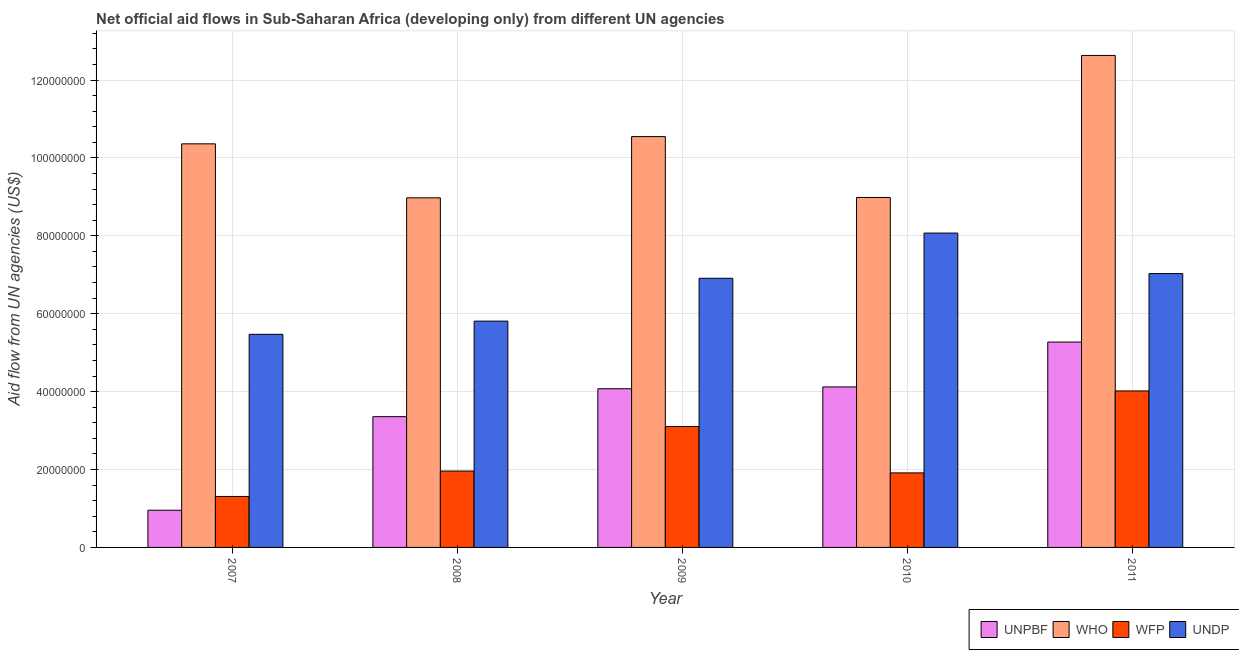Are the number of bars per tick equal to the number of legend labels?
Provide a succinct answer. Yes. How many bars are there on the 2nd tick from the right?
Give a very brief answer. 4. What is the label of the 1st group of bars from the left?
Ensure brevity in your answer.  2007. What is the amount of aid given by unpbf in 2007?
Ensure brevity in your answer.  9.55e+06. Across all years, what is the maximum amount of aid given by undp?
Give a very brief answer. 8.07e+07. Across all years, what is the minimum amount of aid given by unpbf?
Make the answer very short. 9.55e+06. In which year was the amount of aid given by unpbf minimum?
Give a very brief answer. 2007. What is the total amount of aid given by unpbf in the graph?
Offer a terse response. 1.78e+08. What is the difference between the amount of aid given by wfp in 2007 and that in 2009?
Provide a short and direct response. -1.80e+07. What is the difference between the amount of aid given by unpbf in 2008 and the amount of aid given by undp in 2007?
Offer a terse response. 2.40e+07. What is the average amount of aid given by who per year?
Your response must be concise. 1.03e+08. In the year 2010, what is the difference between the amount of aid given by unpbf and amount of aid given by undp?
Give a very brief answer. 0. What is the ratio of the amount of aid given by wfp in 2009 to that in 2010?
Offer a terse response. 1.62. Is the amount of aid given by who in 2008 less than that in 2009?
Offer a terse response. Yes. What is the difference between the highest and the second highest amount of aid given by unpbf?
Offer a terse response. 1.15e+07. What is the difference between the highest and the lowest amount of aid given by who?
Provide a short and direct response. 3.66e+07. Is it the case that in every year, the sum of the amount of aid given by who and amount of aid given by wfp is greater than the sum of amount of aid given by undp and amount of aid given by unpbf?
Keep it short and to the point. No. What does the 2nd bar from the left in 2010 represents?
Your response must be concise. WHO. What does the 2nd bar from the right in 2009 represents?
Ensure brevity in your answer.  WFP. Is it the case that in every year, the sum of the amount of aid given by unpbf and amount of aid given by who is greater than the amount of aid given by wfp?
Your response must be concise. Yes. How many bars are there?
Offer a terse response. 20. How many years are there in the graph?
Provide a short and direct response. 5. What is the difference between two consecutive major ticks on the Y-axis?
Keep it short and to the point. 2.00e+07. Are the values on the major ticks of Y-axis written in scientific E-notation?
Keep it short and to the point. No. Does the graph contain any zero values?
Offer a terse response. No. Where does the legend appear in the graph?
Your answer should be very brief. Bottom right. How are the legend labels stacked?
Offer a very short reply. Horizontal. What is the title of the graph?
Provide a short and direct response. Net official aid flows in Sub-Saharan Africa (developing only) from different UN agencies. What is the label or title of the X-axis?
Ensure brevity in your answer.  Year. What is the label or title of the Y-axis?
Give a very brief answer. Aid flow from UN agencies (US$). What is the Aid flow from UN agencies (US$) in UNPBF in 2007?
Ensure brevity in your answer.  9.55e+06. What is the Aid flow from UN agencies (US$) of WHO in 2007?
Give a very brief answer. 1.04e+08. What is the Aid flow from UN agencies (US$) of WFP in 2007?
Provide a succinct answer. 1.31e+07. What is the Aid flow from UN agencies (US$) of UNDP in 2007?
Provide a succinct answer. 5.47e+07. What is the Aid flow from UN agencies (US$) in UNPBF in 2008?
Provide a short and direct response. 3.36e+07. What is the Aid flow from UN agencies (US$) of WHO in 2008?
Provide a short and direct response. 8.98e+07. What is the Aid flow from UN agencies (US$) of WFP in 2008?
Offer a terse response. 1.96e+07. What is the Aid flow from UN agencies (US$) of UNDP in 2008?
Provide a short and direct response. 5.81e+07. What is the Aid flow from UN agencies (US$) of UNPBF in 2009?
Keep it short and to the point. 4.07e+07. What is the Aid flow from UN agencies (US$) in WHO in 2009?
Keep it short and to the point. 1.05e+08. What is the Aid flow from UN agencies (US$) of WFP in 2009?
Ensure brevity in your answer.  3.10e+07. What is the Aid flow from UN agencies (US$) in UNDP in 2009?
Provide a short and direct response. 6.91e+07. What is the Aid flow from UN agencies (US$) in UNPBF in 2010?
Keep it short and to the point. 4.12e+07. What is the Aid flow from UN agencies (US$) of WHO in 2010?
Keep it short and to the point. 8.98e+07. What is the Aid flow from UN agencies (US$) in WFP in 2010?
Your answer should be compact. 1.91e+07. What is the Aid flow from UN agencies (US$) of UNDP in 2010?
Your response must be concise. 8.07e+07. What is the Aid flow from UN agencies (US$) of UNPBF in 2011?
Your answer should be very brief. 5.27e+07. What is the Aid flow from UN agencies (US$) in WHO in 2011?
Your answer should be very brief. 1.26e+08. What is the Aid flow from UN agencies (US$) in WFP in 2011?
Your answer should be compact. 4.02e+07. What is the Aid flow from UN agencies (US$) in UNDP in 2011?
Your response must be concise. 7.03e+07. Across all years, what is the maximum Aid flow from UN agencies (US$) of UNPBF?
Your answer should be compact. 5.27e+07. Across all years, what is the maximum Aid flow from UN agencies (US$) of WHO?
Ensure brevity in your answer.  1.26e+08. Across all years, what is the maximum Aid flow from UN agencies (US$) in WFP?
Ensure brevity in your answer.  4.02e+07. Across all years, what is the maximum Aid flow from UN agencies (US$) in UNDP?
Give a very brief answer. 8.07e+07. Across all years, what is the minimum Aid flow from UN agencies (US$) in UNPBF?
Give a very brief answer. 9.55e+06. Across all years, what is the minimum Aid flow from UN agencies (US$) in WHO?
Make the answer very short. 8.98e+07. Across all years, what is the minimum Aid flow from UN agencies (US$) of WFP?
Your answer should be compact. 1.31e+07. Across all years, what is the minimum Aid flow from UN agencies (US$) of UNDP?
Keep it short and to the point. 5.47e+07. What is the total Aid flow from UN agencies (US$) in UNPBF in the graph?
Your answer should be compact. 1.78e+08. What is the total Aid flow from UN agencies (US$) of WHO in the graph?
Your response must be concise. 5.15e+08. What is the total Aid flow from UN agencies (US$) in WFP in the graph?
Offer a terse response. 1.23e+08. What is the total Aid flow from UN agencies (US$) in UNDP in the graph?
Keep it short and to the point. 3.33e+08. What is the difference between the Aid flow from UN agencies (US$) of UNPBF in 2007 and that in 2008?
Your response must be concise. -2.40e+07. What is the difference between the Aid flow from UN agencies (US$) of WHO in 2007 and that in 2008?
Keep it short and to the point. 1.39e+07. What is the difference between the Aid flow from UN agencies (US$) of WFP in 2007 and that in 2008?
Provide a short and direct response. -6.53e+06. What is the difference between the Aid flow from UN agencies (US$) of UNDP in 2007 and that in 2008?
Your response must be concise. -3.39e+06. What is the difference between the Aid flow from UN agencies (US$) in UNPBF in 2007 and that in 2009?
Your answer should be compact. -3.12e+07. What is the difference between the Aid flow from UN agencies (US$) of WHO in 2007 and that in 2009?
Your answer should be compact. -1.86e+06. What is the difference between the Aid flow from UN agencies (US$) of WFP in 2007 and that in 2009?
Keep it short and to the point. -1.80e+07. What is the difference between the Aid flow from UN agencies (US$) in UNDP in 2007 and that in 2009?
Make the answer very short. -1.44e+07. What is the difference between the Aid flow from UN agencies (US$) of UNPBF in 2007 and that in 2010?
Make the answer very short. -3.17e+07. What is the difference between the Aid flow from UN agencies (US$) in WHO in 2007 and that in 2010?
Your answer should be very brief. 1.38e+07. What is the difference between the Aid flow from UN agencies (US$) in WFP in 2007 and that in 2010?
Offer a very short reply. -6.06e+06. What is the difference between the Aid flow from UN agencies (US$) in UNDP in 2007 and that in 2010?
Your answer should be compact. -2.60e+07. What is the difference between the Aid flow from UN agencies (US$) of UNPBF in 2007 and that in 2011?
Ensure brevity in your answer.  -4.32e+07. What is the difference between the Aid flow from UN agencies (US$) in WHO in 2007 and that in 2011?
Your answer should be compact. -2.27e+07. What is the difference between the Aid flow from UN agencies (US$) of WFP in 2007 and that in 2011?
Your response must be concise. -2.71e+07. What is the difference between the Aid flow from UN agencies (US$) in UNDP in 2007 and that in 2011?
Provide a succinct answer. -1.56e+07. What is the difference between the Aid flow from UN agencies (US$) of UNPBF in 2008 and that in 2009?
Your answer should be very brief. -7.17e+06. What is the difference between the Aid flow from UN agencies (US$) in WHO in 2008 and that in 2009?
Make the answer very short. -1.57e+07. What is the difference between the Aid flow from UN agencies (US$) in WFP in 2008 and that in 2009?
Offer a very short reply. -1.14e+07. What is the difference between the Aid flow from UN agencies (US$) of UNDP in 2008 and that in 2009?
Provide a succinct answer. -1.10e+07. What is the difference between the Aid flow from UN agencies (US$) in UNPBF in 2008 and that in 2010?
Your response must be concise. -7.64e+06. What is the difference between the Aid flow from UN agencies (US$) in WFP in 2008 and that in 2010?
Make the answer very short. 4.70e+05. What is the difference between the Aid flow from UN agencies (US$) of UNDP in 2008 and that in 2010?
Your answer should be very brief. -2.26e+07. What is the difference between the Aid flow from UN agencies (US$) of UNPBF in 2008 and that in 2011?
Ensure brevity in your answer.  -1.92e+07. What is the difference between the Aid flow from UN agencies (US$) in WHO in 2008 and that in 2011?
Your response must be concise. -3.66e+07. What is the difference between the Aid flow from UN agencies (US$) of WFP in 2008 and that in 2011?
Give a very brief answer. -2.06e+07. What is the difference between the Aid flow from UN agencies (US$) in UNDP in 2008 and that in 2011?
Offer a terse response. -1.22e+07. What is the difference between the Aid flow from UN agencies (US$) of UNPBF in 2009 and that in 2010?
Your answer should be compact. -4.70e+05. What is the difference between the Aid flow from UN agencies (US$) of WHO in 2009 and that in 2010?
Provide a succinct answer. 1.56e+07. What is the difference between the Aid flow from UN agencies (US$) of WFP in 2009 and that in 2010?
Your answer should be very brief. 1.19e+07. What is the difference between the Aid flow from UN agencies (US$) of UNDP in 2009 and that in 2010?
Offer a terse response. -1.16e+07. What is the difference between the Aid flow from UN agencies (US$) in UNPBF in 2009 and that in 2011?
Ensure brevity in your answer.  -1.20e+07. What is the difference between the Aid flow from UN agencies (US$) in WHO in 2009 and that in 2011?
Your answer should be compact. -2.08e+07. What is the difference between the Aid flow from UN agencies (US$) in WFP in 2009 and that in 2011?
Your answer should be very brief. -9.14e+06. What is the difference between the Aid flow from UN agencies (US$) of UNDP in 2009 and that in 2011?
Ensure brevity in your answer.  -1.20e+06. What is the difference between the Aid flow from UN agencies (US$) in UNPBF in 2010 and that in 2011?
Provide a succinct answer. -1.15e+07. What is the difference between the Aid flow from UN agencies (US$) in WHO in 2010 and that in 2011?
Offer a very short reply. -3.65e+07. What is the difference between the Aid flow from UN agencies (US$) in WFP in 2010 and that in 2011?
Your answer should be very brief. -2.10e+07. What is the difference between the Aid flow from UN agencies (US$) of UNDP in 2010 and that in 2011?
Offer a very short reply. 1.04e+07. What is the difference between the Aid flow from UN agencies (US$) in UNPBF in 2007 and the Aid flow from UN agencies (US$) in WHO in 2008?
Your response must be concise. -8.02e+07. What is the difference between the Aid flow from UN agencies (US$) of UNPBF in 2007 and the Aid flow from UN agencies (US$) of WFP in 2008?
Your response must be concise. -1.01e+07. What is the difference between the Aid flow from UN agencies (US$) of UNPBF in 2007 and the Aid flow from UN agencies (US$) of UNDP in 2008?
Ensure brevity in your answer.  -4.86e+07. What is the difference between the Aid flow from UN agencies (US$) in WHO in 2007 and the Aid flow from UN agencies (US$) in WFP in 2008?
Keep it short and to the point. 8.40e+07. What is the difference between the Aid flow from UN agencies (US$) of WHO in 2007 and the Aid flow from UN agencies (US$) of UNDP in 2008?
Provide a short and direct response. 4.55e+07. What is the difference between the Aid flow from UN agencies (US$) in WFP in 2007 and the Aid flow from UN agencies (US$) in UNDP in 2008?
Your answer should be compact. -4.50e+07. What is the difference between the Aid flow from UN agencies (US$) in UNPBF in 2007 and the Aid flow from UN agencies (US$) in WHO in 2009?
Keep it short and to the point. -9.59e+07. What is the difference between the Aid flow from UN agencies (US$) of UNPBF in 2007 and the Aid flow from UN agencies (US$) of WFP in 2009?
Provide a short and direct response. -2.15e+07. What is the difference between the Aid flow from UN agencies (US$) of UNPBF in 2007 and the Aid flow from UN agencies (US$) of UNDP in 2009?
Provide a succinct answer. -5.96e+07. What is the difference between the Aid flow from UN agencies (US$) in WHO in 2007 and the Aid flow from UN agencies (US$) in WFP in 2009?
Your response must be concise. 7.26e+07. What is the difference between the Aid flow from UN agencies (US$) of WHO in 2007 and the Aid flow from UN agencies (US$) of UNDP in 2009?
Provide a succinct answer. 3.45e+07. What is the difference between the Aid flow from UN agencies (US$) in WFP in 2007 and the Aid flow from UN agencies (US$) in UNDP in 2009?
Provide a short and direct response. -5.60e+07. What is the difference between the Aid flow from UN agencies (US$) in UNPBF in 2007 and the Aid flow from UN agencies (US$) in WHO in 2010?
Your response must be concise. -8.03e+07. What is the difference between the Aid flow from UN agencies (US$) in UNPBF in 2007 and the Aid flow from UN agencies (US$) in WFP in 2010?
Offer a terse response. -9.59e+06. What is the difference between the Aid flow from UN agencies (US$) in UNPBF in 2007 and the Aid flow from UN agencies (US$) in UNDP in 2010?
Make the answer very short. -7.12e+07. What is the difference between the Aid flow from UN agencies (US$) of WHO in 2007 and the Aid flow from UN agencies (US$) of WFP in 2010?
Keep it short and to the point. 8.45e+07. What is the difference between the Aid flow from UN agencies (US$) in WHO in 2007 and the Aid flow from UN agencies (US$) in UNDP in 2010?
Offer a very short reply. 2.29e+07. What is the difference between the Aid flow from UN agencies (US$) of WFP in 2007 and the Aid flow from UN agencies (US$) of UNDP in 2010?
Ensure brevity in your answer.  -6.76e+07. What is the difference between the Aid flow from UN agencies (US$) of UNPBF in 2007 and the Aid flow from UN agencies (US$) of WHO in 2011?
Your answer should be very brief. -1.17e+08. What is the difference between the Aid flow from UN agencies (US$) of UNPBF in 2007 and the Aid flow from UN agencies (US$) of WFP in 2011?
Your response must be concise. -3.06e+07. What is the difference between the Aid flow from UN agencies (US$) in UNPBF in 2007 and the Aid flow from UN agencies (US$) in UNDP in 2011?
Your answer should be compact. -6.08e+07. What is the difference between the Aid flow from UN agencies (US$) in WHO in 2007 and the Aid flow from UN agencies (US$) in WFP in 2011?
Provide a succinct answer. 6.34e+07. What is the difference between the Aid flow from UN agencies (US$) in WHO in 2007 and the Aid flow from UN agencies (US$) in UNDP in 2011?
Give a very brief answer. 3.33e+07. What is the difference between the Aid flow from UN agencies (US$) in WFP in 2007 and the Aid flow from UN agencies (US$) in UNDP in 2011?
Provide a short and direct response. -5.72e+07. What is the difference between the Aid flow from UN agencies (US$) in UNPBF in 2008 and the Aid flow from UN agencies (US$) in WHO in 2009?
Provide a short and direct response. -7.19e+07. What is the difference between the Aid flow from UN agencies (US$) of UNPBF in 2008 and the Aid flow from UN agencies (US$) of WFP in 2009?
Keep it short and to the point. 2.53e+06. What is the difference between the Aid flow from UN agencies (US$) of UNPBF in 2008 and the Aid flow from UN agencies (US$) of UNDP in 2009?
Ensure brevity in your answer.  -3.55e+07. What is the difference between the Aid flow from UN agencies (US$) in WHO in 2008 and the Aid flow from UN agencies (US$) in WFP in 2009?
Offer a very short reply. 5.87e+07. What is the difference between the Aid flow from UN agencies (US$) in WHO in 2008 and the Aid flow from UN agencies (US$) in UNDP in 2009?
Your response must be concise. 2.06e+07. What is the difference between the Aid flow from UN agencies (US$) in WFP in 2008 and the Aid flow from UN agencies (US$) in UNDP in 2009?
Your response must be concise. -4.95e+07. What is the difference between the Aid flow from UN agencies (US$) in UNPBF in 2008 and the Aid flow from UN agencies (US$) in WHO in 2010?
Ensure brevity in your answer.  -5.63e+07. What is the difference between the Aid flow from UN agencies (US$) in UNPBF in 2008 and the Aid flow from UN agencies (US$) in WFP in 2010?
Keep it short and to the point. 1.44e+07. What is the difference between the Aid flow from UN agencies (US$) in UNPBF in 2008 and the Aid flow from UN agencies (US$) in UNDP in 2010?
Keep it short and to the point. -4.71e+07. What is the difference between the Aid flow from UN agencies (US$) in WHO in 2008 and the Aid flow from UN agencies (US$) in WFP in 2010?
Offer a very short reply. 7.06e+07. What is the difference between the Aid flow from UN agencies (US$) of WHO in 2008 and the Aid flow from UN agencies (US$) of UNDP in 2010?
Your answer should be very brief. 9.05e+06. What is the difference between the Aid flow from UN agencies (US$) in WFP in 2008 and the Aid flow from UN agencies (US$) in UNDP in 2010?
Ensure brevity in your answer.  -6.11e+07. What is the difference between the Aid flow from UN agencies (US$) of UNPBF in 2008 and the Aid flow from UN agencies (US$) of WHO in 2011?
Offer a very short reply. -9.28e+07. What is the difference between the Aid flow from UN agencies (US$) of UNPBF in 2008 and the Aid flow from UN agencies (US$) of WFP in 2011?
Give a very brief answer. -6.61e+06. What is the difference between the Aid flow from UN agencies (US$) in UNPBF in 2008 and the Aid flow from UN agencies (US$) in UNDP in 2011?
Your response must be concise. -3.67e+07. What is the difference between the Aid flow from UN agencies (US$) in WHO in 2008 and the Aid flow from UN agencies (US$) in WFP in 2011?
Offer a very short reply. 4.96e+07. What is the difference between the Aid flow from UN agencies (US$) of WHO in 2008 and the Aid flow from UN agencies (US$) of UNDP in 2011?
Provide a short and direct response. 1.94e+07. What is the difference between the Aid flow from UN agencies (US$) in WFP in 2008 and the Aid flow from UN agencies (US$) in UNDP in 2011?
Give a very brief answer. -5.07e+07. What is the difference between the Aid flow from UN agencies (US$) of UNPBF in 2009 and the Aid flow from UN agencies (US$) of WHO in 2010?
Provide a short and direct response. -4.91e+07. What is the difference between the Aid flow from UN agencies (US$) of UNPBF in 2009 and the Aid flow from UN agencies (US$) of WFP in 2010?
Your response must be concise. 2.16e+07. What is the difference between the Aid flow from UN agencies (US$) of UNPBF in 2009 and the Aid flow from UN agencies (US$) of UNDP in 2010?
Ensure brevity in your answer.  -4.00e+07. What is the difference between the Aid flow from UN agencies (US$) of WHO in 2009 and the Aid flow from UN agencies (US$) of WFP in 2010?
Offer a terse response. 8.63e+07. What is the difference between the Aid flow from UN agencies (US$) in WHO in 2009 and the Aid flow from UN agencies (US$) in UNDP in 2010?
Your answer should be compact. 2.48e+07. What is the difference between the Aid flow from UN agencies (US$) of WFP in 2009 and the Aid flow from UN agencies (US$) of UNDP in 2010?
Your answer should be very brief. -4.97e+07. What is the difference between the Aid flow from UN agencies (US$) of UNPBF in 2009 and the Aid flow from UN agencies (US$) of WHO in 2011?
Your answer should be very brief. -8.56e+07. What is the difference between the Aid flow from UN agencies (US$) in UNPBF in 2009 and the Aid flow from UN agencies (US$) in WFP in 2011?
Give a very brief answer. 5.60e+05. What is the difference between the Aid flow from UN agencies (US$) in UNPBF in 2009 and the Aid flow from UN agencies (US$) in UNDP in 2011?
Offer a very short reply. -2.96e+07. What is the difference between the Aid flow from UN agencies (US$) of WHO in 2009 and the Aid flow from UN agencies (US$) of WFP in 2011?
Keep it short and to the point. 6.53e+07. What is the difference between the Aid flow from UN agencies (US$) in WHO in 2009 and the Aid flow from UN agencies (US$) in UNDP in 2011?
Your answer should be compact. 3.52e+07. What is the difference between the Aid flow from UN agencies (US$) of WFP in 2009 and the Aid flow from UN agencies (US$) of UNDP in 2011?
Your answer should be compact. -3.93e+07. What is the difference between the Aid flow from UN agencies (US$) in UNPBF in 2010 and the Aid flow from UN agencies (US$) in WHO in 2011?
Your answer should be very brief. -8.51e+07. What is the difference between the Aid flow from UN agencies (US$) of UNPBF in 2010 and the Aid flow from UN agencies (US$) of WFP in 2011?
Your response must be concise. 1.03e+06. What is the difference between the Aid flow from UN agencies (US$) in UNPBF in 2010 and the Aid flow from UN agencies (US$) in UNDP in 2011?
Provide a short and direct response. -2.91e+07. What is the difference between the Aid flow from UN agencies (US$) in WHO in 2010 and the Aid flow from UN agencies (US$) in WFP in 2011?
Give a very brief answer. 4.97e+07. What is the difference between the Aid flow from UN agencies (US$) in WHO in 2010 and the Aid flow from UN agencies (US$) in UNDP in 2011?
Ensure brevity in your answer.  1.95e+07. What is the difference between the Aid flow from UN agencies (US$) in WFP in 2010 and the Aid flow from UN agencies (US$) in UNDP in 2011?
Your answer should be very brief. -5.12e+07. What is the average Aid flow from UN agencies (US$) in UNPBF per year?
Provide a short and direct response. 3.56e+07. What is the average Aid flow from UN agencies (US$) of WHO per year?
Ensure brevity in your answer.  1.03e+08. What is the average Aid flow from UN agencies (US$) in WFP per year?
Provide a succinct answer. 2.46e+07. What is the average Aid flow from UN agencies (US$) of UNDP per year?
Your answer should be very brief. 6.66e+07. In the year 2007, what is the difference between the Aid flow from UN agencies (US$) in UNPBF and Aid flow from UN agencies (US$) in WHO?
Your response must be concise. -9.41e+07. In the year 2007, what is the difference between the Aid flow from UN agencies (US$) of UNPBF and Aid flow from UN agencies (US$) of WFP?
Your answer should be very brief. -3.53e+06. In the year 2007, what is the difference between the Aid flow from UN agencies (US$) in UNPBF and Aid flow from UN agencies (US$) in UNDP?
Keep it short and to the point. -4.52e+07. In the year 2007, what is the difference between the Aid flow from UN agencies (US$) in WHO and Aid flow from UN agencies (US$) in WFP?
Your answer should be very brief. 9.05e+07. In the year 2007, what is the difference between the Aid flow from UN agencies (US$) in WHO and Aid flow from UN agencies (US$) in UNDP?
Offer a very short reply. 4.89e+07. In the year 2007, what is the difference between the Aid flow from UN agencies (US$) in WFP and Aid flow from UN agencies (US$) in UNDP?
Your answer should be compact. -4.16e+07. In the year 2008, what is the difference between the Aid flow from UN agencies (US$) of UNPBF and Aid flow from UN agencies (US$) of WHO?
Offer a very short reply. -5.62e+07. In the year 2008, what is the difference between the Aid flow from UN agencies (US$) of UNPBF and Aid flow from UN agencies (US$) of WFP?
Give a very brief answer. 1.40e+07. In the year 2008, what is the difference between the Aid flow from UN agencies (US$) of UNPBF and Aid flow from UN agencies (US$) of UNDP?
Give a very brief answer. -2.45e+07. In the year 2008, what is the difference between the Aid flow from UN agencies (US$) of WHO and Aid flow from UN agencies (US$) of WFP?
Provide a short and direct response. 7.02e+07. In the year 2008, what is the difference between the Aid flow from UN agencies (US$) of WHO and Aid flow from UN agencies (US$) of UNDP?
Offer a very short reply. 3.17e+07. In the year 2008, what is the difference between the Aid flow from UN agencies (US$) of WFP and Aid flow from UN agencies (US$) of UNDP?
Offer a terse response. -3.85e+07. In the year 2009, what is the difference between the Aid flow from UN agencies (US$) of UNPBF and Aid flow from UN agencies (US$) of WHO?
Your response must be concise. -6.47e+07. In the year 2009, what is the difference between the Aid flow from UN agencies (US$) of UNPBF and Aid flow from UN agencies (US$) of WFP?
Your response must be concise. 9.70e+06. In the year 2009, what is the difference between the Aid flow from UN agencies (US$) in UNPBF and Aid flow from UN agencies (US$) in UNDP?
Give a very brief answer. -2.84e+07. In the year 2009, what is the difference between the Aid flow from UN agencies (US$) of WHO and Aid flow from UN agencies (US$) of WFP?
Offer a terse response. 7.44e+07. In the year 2009, what is the difference between the Aid flow from UN agencies (US$) of WHO and Aid flow from UN agencies (US$) of UNDP?
Offer a terse response. 3.64e+07. In the year 2009, what is the difference between the Aid flow from UN agencies (US$) in WFP and Aid flow from UN agencies (US$) in UNDP?
Offer a very short reply. -3.81e+07. In the year 2010, what is the difference between the Aid flow from UN agencies (US$) of UNPBF and Aid flow from UN agencies (US$) of WHO?
Ensure brevity in your answer.  -4.86e+07. In the year 2010, what is the difference between the Aid flow from UN agencies (US$) in UNPBF and Aid flow from UN agencies (US$) in WFP?
Provide a succinct answer. 2.21e+07. In the year 2010, what is the difference between the Aid flow from UN agencies (US$) in UNPBF and Aid flow from UN agencies (US$) in UNDP?
Ensure brevity in your answer.  -3.95e+07. In the year 2010, what is the difference between the Aid flow from UN agencies (US$) in WHO and Aid flow from UN agencies (US$) in WFP?
Keep it short and to the point. 7.07e+07. In the year 2010, what is the difference between the Aid flow from UN agencies (US$) of WHO and Aid flow from UN agencies (US$) of UNDP?
Offer a terse response. 9.14e+06. In the year 2010, what is the difference between the Aid flow from UN agencies (US$) of WFP and Aid flow from UN agencies (US$) of UNDP?
Your answer should be compact. -6.16e+07. In the year 2011, what is the difference between the Aid flow from UN agencies (US$) of UNPBF and Aid flow from UN agencies (US$) of WHO?
Ensure brevity in your answer.  -7.36e+07. In the year 2011, what is the difference between the Aid flow from UN agencies (US$) of UNPBF and Aid flow from UN agencies (US$) of WFP?
Offer a terse response. 1.26e+07. In the year 2011, what is the difference between the Aid flow from UN agencies (US$) of UNPBF and Aid flow from UN agencies (US$) of UNDP?
Offer a very short reply. -1.76e+07. In the year 2011, what is the difference between the Aid flow from UN agencies (US$) of WHO and Aid flow from UN agencies (US$) of WFP?
Offer a very short reply. 8.61e+07. In the year 2011, what is the difference between the Aid flow from UN agencies (US$) of WHO and Aid flow from UN agencies (US$) of UNDP?
Offer a terse response. 5.60e+07. In the year 2011, what is the difference between the Aid flow from UN agencies (US$) of WFP and Aid flow from UN agencies (US$) of UNDP?
Offer a very short reply. -3.01e+07. What is the ratio of the Aid flow from UN agencies (US$) in UNPBF in 2007 to that in 2008?
Your response must be concise. 0.28. What is the ratio of the Aid flow from UN agencies (US$) in WHO in 2007 to that in 2008?
Your response must be concise. 1.15. What is the ratio of the Aid flow from UN agencies (US$) of WFP in 2007 to that in 2008?
Give a very brief answer. 0.67. What is the ratio of the Aid flow from UN agencies (US$) of UNDP in 2007 to that in 2008?
Offer a terse response. 0.94. What is the ratio of the Aid flow from UN agencies (US$) of UNPBF in 2007 to that in 2009?
Offer a very short reply. 0.23. What is the ratio of the Aid flow from UN agencies (US$) in WHO in 2007 to that in 2009?
Keep it short and to the point. 0.98. What is the ratio of the Aid flow from UN agencies (US$) of WFP in 2007 to that in 2009?
Offer a terse response. 0.42. What is the ratio of the Aid flow from UN agencies (US$) of UNDP in 2007 to that in 2009?
Ensure brevity in your answer.  0.79. What is the ratio of the Aid flow from UN agencies (US$) in UNPBF in 2007 to that in 2010?
Make the answer very short. 0.23. What is the ratio of the Aid flow from UN agencies (US$) in WHO in 2007 to that in 2010?
Keep it short and to the point. 1.15. What is the ratio of the Aid flow from UN agencies (US$) of WFP in 2007 to that in 2010?
Give a very brief answer. 0.68. What is the ratio of the Aid flow from UN agencies (US$) of UNDP in 2007 to that in 2010?
Your response must be concise. 0.68. What is the ratio of the Aid flow from UN agencies (US$) in UNPBF in 2007 to that in 2011?
Your answer should be very brief. 0.18. What is the ratio of the Aid flow from UN agencies (US$) of WHO in 2007 to that in 2011?
Make the answer very short. 0.82. What is the ratio of the Aid flow from UN agencies (US$) of WFP in 2007 to that in 2011?
Offer a terse response. 0.33. What is the ratio of the Aid flow from UN agencies (US$) of UNDP in 2007 to that in 2011?
Your response must be concise. 0.78. What is the ratio of the Aid flow from UN agencies (US$) of UNPBF in 2008 to that in 2009?
Your answer should be very brief. 0.82. What is the ratio of the Aid flow from UN agencies (US$) in WHO in 2008 to that in 2009?
Your answer should be compact. 0.85. What is the ratio of the Aid flow from UN agencies (US$) in WFP in 2008 to that in 2009?
Provide a short and direct response. 0.63. What is the ratio of the Aid flow from UN agencies (US$) in UNDP in 2008 to that in 2009?
Your response must be concise. 0.84. What is the ratio of the Aid flow from UN agencies (US$) of UNPBF in 2008 to that in 2010?
Provide a short and direct response. 0.81. What is the ratio of the Aid flow from UN agencies (US$) in WHO in 2008 to that in 2010?
Provide a short and direct response. 1. What is the ratio of the Aid flow from UN agencies (US$) of WFP in 2008 to that in 2010?
Make the answer very short. 1.02. What is the ratio of the Aid flow from UN agencies (US$) in UNDP in 2008 to that in 2010?
Provide a short and direct response. 0.72. What is the ratio of the Aid flow from UN agencies (US$) in UNPBF in 2008 to that in 2011?
Provide a succinct answer. 0.64. What is the ratio of the Aid flow from UN agencies (US$) in WHO in 2008 to that in 2011?
Your answer should be compact. 0.71. What is the ratio of the Aid flow from UN agencies (US$) of WFP in 2008 to that in 2011?
Your response must be concise. 0.49. What is the ratio of the Aid flow from UN agencies (US$) in UNDP in 2008 to that in 2011?
Your response must be concise. 0.83. What is the ratio of the Aid flow from UN agencies (US$) of WHO in 2009 to that in 2010?
Give a very brief answer. 1.17. What is the ratio of the Aid flow from UN agencies (US$) in WFP in 2009 to that in 2010?
Make the answer very short. 1.62. What is the ratio of the Aid flow from UN agencies (US$) of UNDP in 2009 to that in 2010?
Your answer should be very brief. 0.86. What is the ratio of the Aid flow from UN agencies (US$) in UNPBF in 2009 to that in 2011?
Offer a very short reply. 0.77. What is the ratio of the Aid flow from UN agencies (US$) of WHO in 2009 to that in 2011?
Ensure brevity in your answer.  0.83. What is the ratio of the Aid flow from UN agencies (US$) of WFP in 2009 to that in 2011?
Offer a very short reply. 0.77. What is the ratio of the Aid flow from UN agencies (US$) in UNDP in 2009 to that in 2011?
Your response must be concise. 0.98. What is the ratio of the Aid flow from UN agencies (US$) in UNPBF in 2010 to that in 2011?
Provide a short and direct response. 0.78. What is the ratio of the Aid flow from UN agencies (US$) in WHO in 2010 to that in 2011?
Your response must be concise. 0.71. What is the ratio of the Aid flow from UN agencies (US$) of WFP in 2010 to that in 2011?
Ensure brevity in your answer.  0.48. What is the ratio of the Aid flow from UN agencies (US$) in UNDP in 2010 to that in 2011?
Offer a terse response. 1.15. What is the difference between the highest and the second highest Aid flow from UN agencies (US$) of UNPBF?
Provide a succinct answer. 1.15e+07. What is the difference between the highest and the second highest Aid flow from UN agencies (US$) in WHO?
Keep it short and to the point. 2.08e+07. What is the difference between the highest and the second highest Aid flow from UN agencies (US$) of WFP?
Make the answer very short. 9.14e+06. What is the difference between the highest and the second highest Aid flow from UN agencies (US$) of UNDP?
Your response must be concise. 1.04e+07. What is the difference between the highest and the lowest Aid flow from UN agencies (US$) of UNPBF?
Give a very brief answer. 4.32e+07. What is the difference between the highest and the lowest Aid flow from UN agencies (US$) in WHO?
Offer a very short reply. 3.66e+07. What is the difference between the highest and the lowest Aid flow from UN agencies (US$) in WFP?
Give a very brief answer. 2.71e+07. What is the difference between the highest and the lowest Aid flow from UN agencies (US$) in UNDP?
Your answer should be very brief. 2.60e+07. 